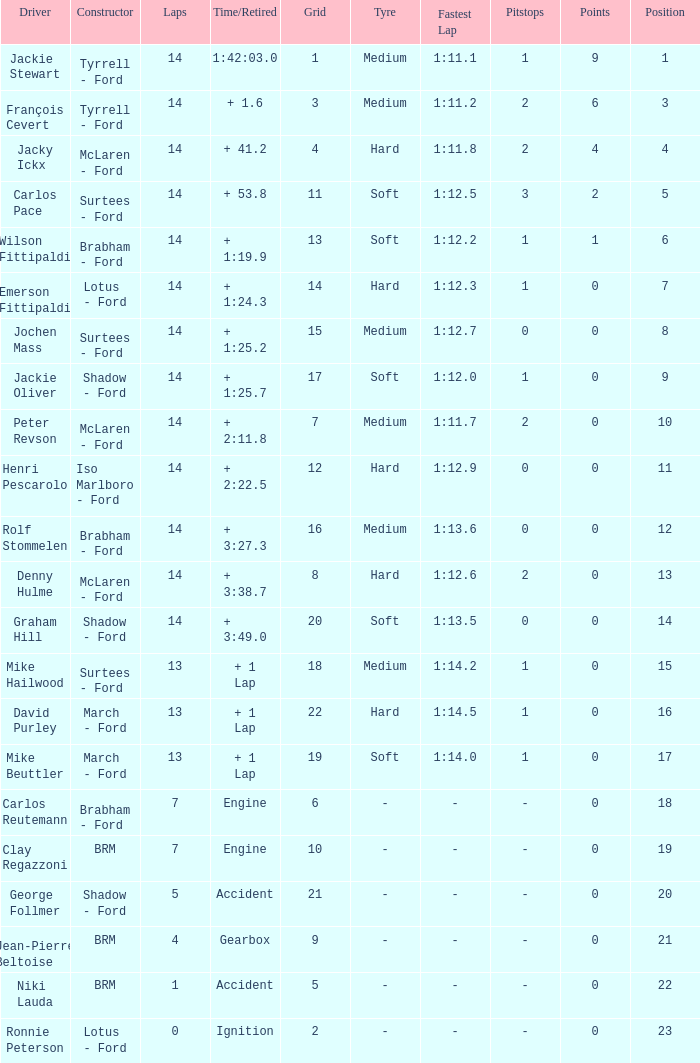What grad has a Time/Retired of + 1:24.3? 14.0. 